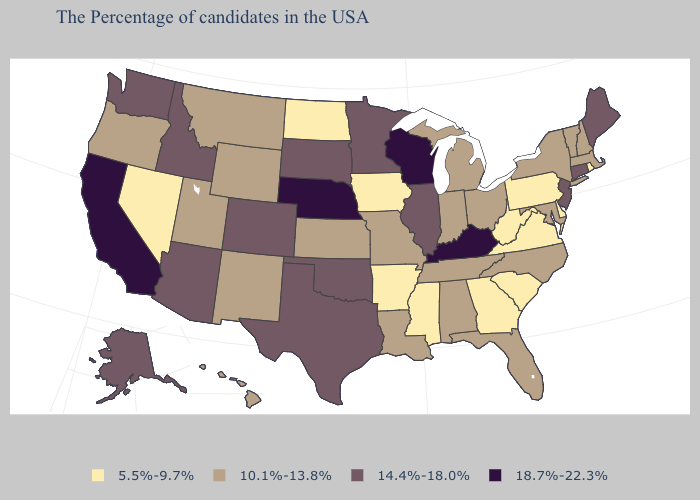Name the states that have a value in the range 10.1%-13.8%?
Answer briefly. Massachusetts, New Hampshire, Vermont, New York, Maryland, North Carolina, Ohio, Florida, Michigan, Indiana, Alabama, Tennessee, Louisiana, Missouri, Kansas, Wyoming, New Mexico, Utah, Montana, Oregon, Hawaii. Does Illinois have a lower value than Nebraska?
Keep it brief. Yes. Does Wisconsin have the highest value in the USA?
Write a very short answer. Yes. Does Iowa have the lowest value in the MidWest?
Short answer required. Yes. How many symbols are there in the legend?
Answer briefly. 4. Does Nebraska have a higher value than Kentucky?
Keep it brief. No. Does Oregon have the highest value in the USA?
Short answer required. No. What is the value of New Mexico?
Short answer required. 10.1%-13.8%. Name the states that have a value in the range 18.7%-22.3%?
Keep it brief. Kentucky, Wisconsin, Nebraska, California. Name the states that have a value in the range 18.7%-22.3%?
Concise answer only. Kentucky, Wisconsin, Nebraska, California. Among the states that border Pennsylvania , which have the lowest value?
Short answer required. Delaware, West Virginia. What is the lowest value in the USA?
Quick response, please. 5.5%-9.7%. What is the value of Utah?
Be succinct. 10.1%-13.8%. Name the states that have a value in the range 10.1%-13.8%?
Concise answer only. Massachusetts, New Hampshire, Vermont, New York, Maryland, North Carolina, Ohio, Florida, Michigan, Indiana, Alabama, Tennessee, Louisiana, Missouri, Kansas, Wyoming, New Mexico, Utah, Montana, Oregon, Hawaii. 